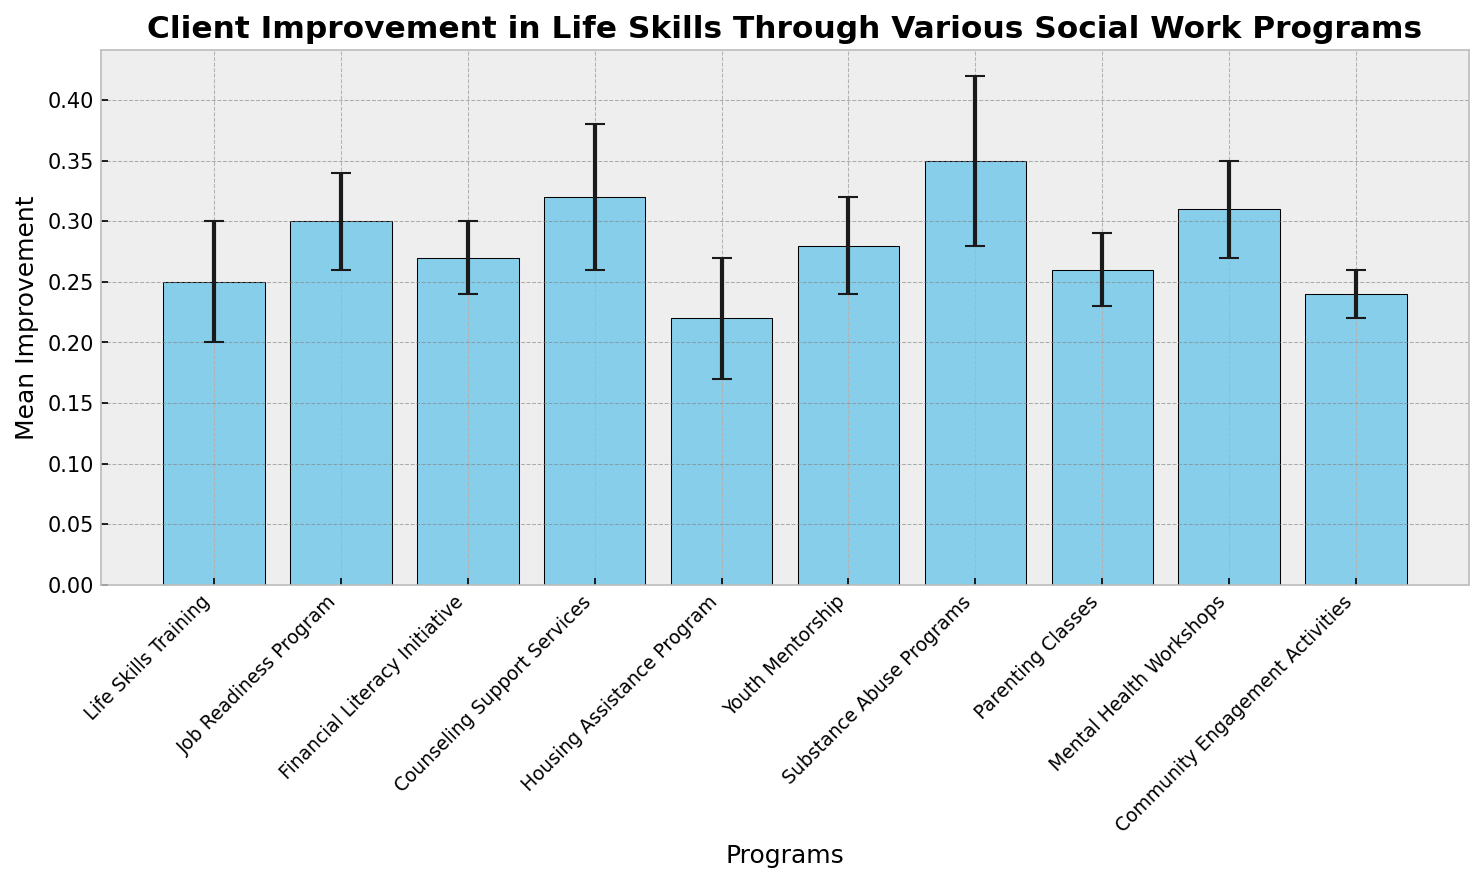What's the mean improvement for the Counseling Support Services program? Identify the bar labeled "Counseling Support Services" and read its height, which is 0.32
Answer: 0.32 Which program shows the highest mean improvement? Compare the heights of all bars to find the tallest one, which represents the "Substance Abuse Programs" with a mean improvement of 0.35
Answer: Substance Abuse Programs How does the mean improvement of the Life Skills Training program compare to the Youth Mentorship program? Look at the heights of the bars for both programs: Life Skills Training (0.25) and Youth Mentorship (0.28). Youth Mentorship is higher
Answer: Youth Mentorship has a higher mean improvement What is the mean improvement difference between the Job Readiness Program and Housing Assistance Program? Subtract the mean improvement of Housing Assistance Program (0.22) from Job Readiness Program (0.30). 0.30 - 0.22 = 0.08
Answer: 0.08 What is the range of mean improvements across all programs? Find the difference between the highest mean improvement (Substance Abuse Programs: 0.35) and the lowest (Housing Assistance Program: 0.22). 0.35 - 0.22 = 0.13
Answer: 0.13 What is the mean improvement of the programs with a standard error of 0.04? Identify bars with a standard error of 0.04: Job Readiness Program (0.30), Youth Mentorship (0.28), Mental Health Workshops (0.31). Calculate the average: (0.30 + 0.28 + 0.31) / 3 = 0.2967
Answer: 0.30 (approximately) Which program has the smallest error margin, and what does that suggest about the results? The bar for Community Engagement Activities has the smallest error margin of 0.02, indicating higher precision and confidence in the mean improvement result for this program
Answer: Community Engagement Activities; higher confidence How many programs have a mean improvement of 0.25 or higher? Count the bars with a mean improvement of 0.25 or higher: Life Skills Training, Job Readiness Program, Financial Literacy Initiative, Counseling Support Services, Youth Mentorship, Substance Abuse Programs, Parenting Classes, Mental Health Workshops. There are 8
Answer: 8 What is the difference in error margins between Substance Abuse Programs and Community Engagement Activities? Subtract the error margin of Community Engagement Activities (0.02) from Substance Abuse Programs (0.07). 0.07 - 0.02 = 0.05
Answer: 0.05 Is there any program whose mean improvement is exactly the same as the average mean improvement across all programs? First, calculate the average mean improvement: (Sum of all mean improvements) / 10 = (0.25 + 0.30 + 0.27 + 0.32 + 0.22 + 0.28 + 0.35 + 0.26 + 0.31 + 0.24) / 10 = 0.28. The program matching this value is Youth Mentorship
Answer: Youth Mentorship 